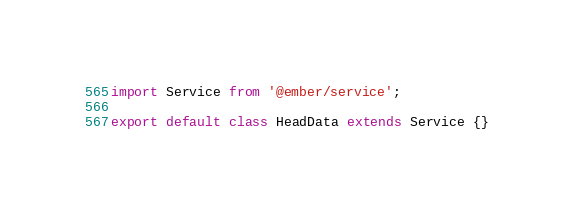<code> <loc_0><loc_0><loc_500><loc_500><_JavaScript_>import Service from '@ember/service';

export default class HeadData extends Service {}
</code> 